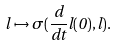Convert formula to latex. <formula><loc_0><loc_0><loc_500><loc_500>l \mapsto \sigma ( \frac { d } { d t } l ( 0 ) , l ) .</formula> 